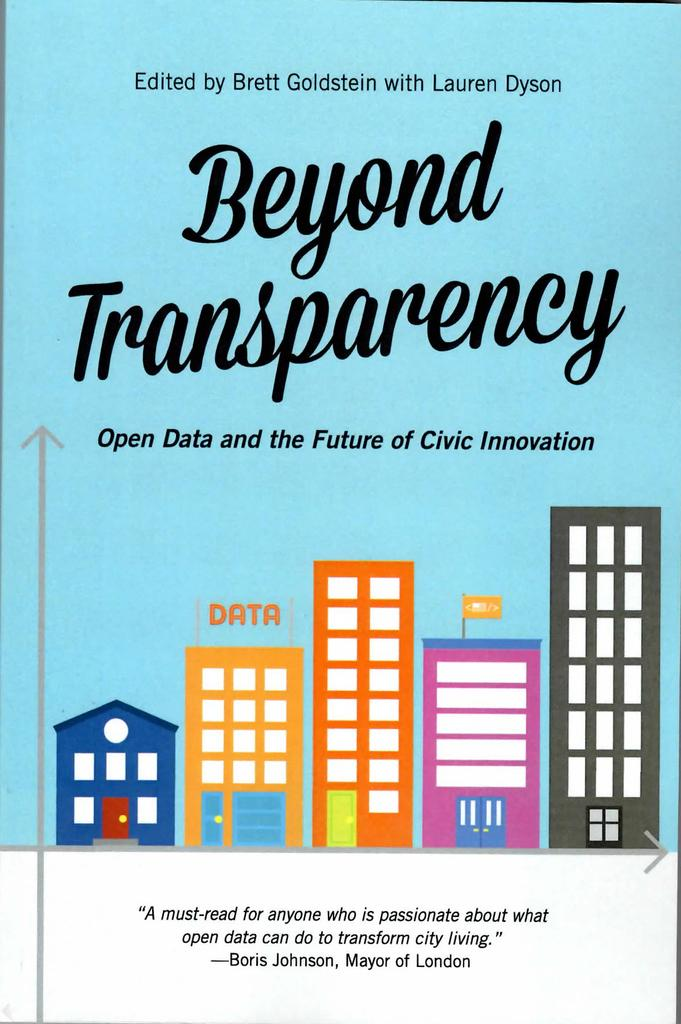<image>
Relay a brief, clear account of the picture shown. a pamphlet that says Beyond Transparency on it 